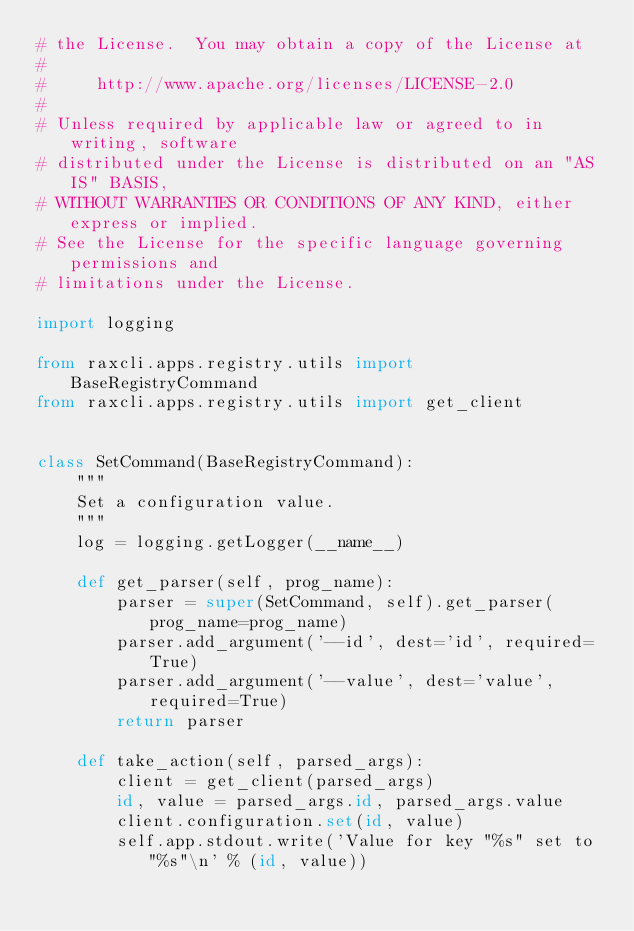<code> <loc_0><loc_0><loc_500><loc_500><_Python_># the License.  You may obtain a copy of the License at
#
#     http://www.apache.org/licenses/LICENSE-2.0
#
# Unless required by applicable law or agreed to in writing, software
# distributed under the License is distributed on an "AS IS" BASIS,
# WITHOUT WARRANTIES OR CONDITIONS OF ANY KIND, either express or implied.
# See the License for the specific language governing permissions and
# limitations under the License.

import logging

from raxcli.apps.registry.utils import BaseRegistryCommand
from raxcli.apps.registry.utils import get_client


class SetCommand(BaseRegistryCommand):
    """
    Set a configuration value.
    """
    log = logging.getLogger(__name__)

    def get_parser(self, prog_name):
        parser = super(SetCommand, self).get_parser(prog_name=prog_name)
        parser.add_argument('--id', dest='id', required=True)
        parser.add_argument('--value', dest='value', required=True)
        return parser

    def take_action(self, parsed_args):
        client = get_client(parsed_args)
        id, value = parsed_args.id, parsed_args.value
        client.configuration.set(id, value)
        self.app.stdout.write('Value for key "%s" set to "%s"\n' % (id, value))
</code> 